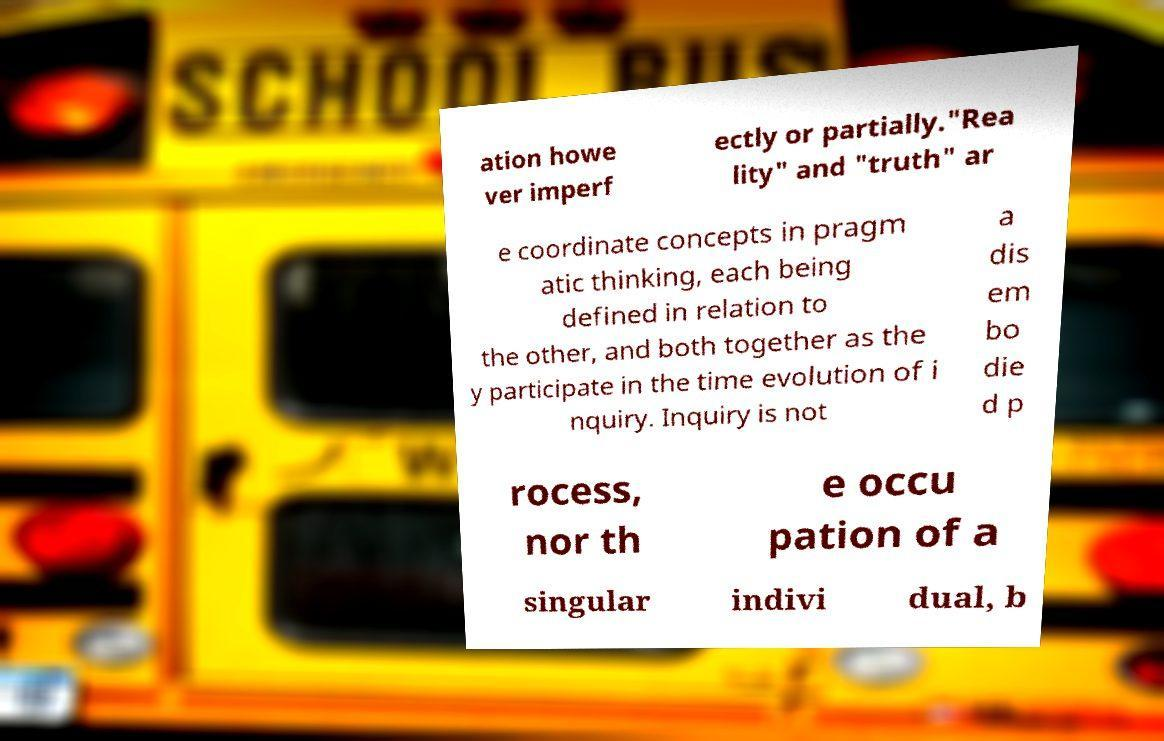Could you assist in decoding the text presented in this image and type it out clearly? ation howe ver imperf ectly or partially."Rea lity" and "truth" ar e coordinate concepts in pragm atic thinking, each being defined in relation to the other, and both together as the y participate in the time evolution of i nquiry. Inquiry is not a dis em bo die d p rocess, nor th e occu pation of a singular indivi dual, b 